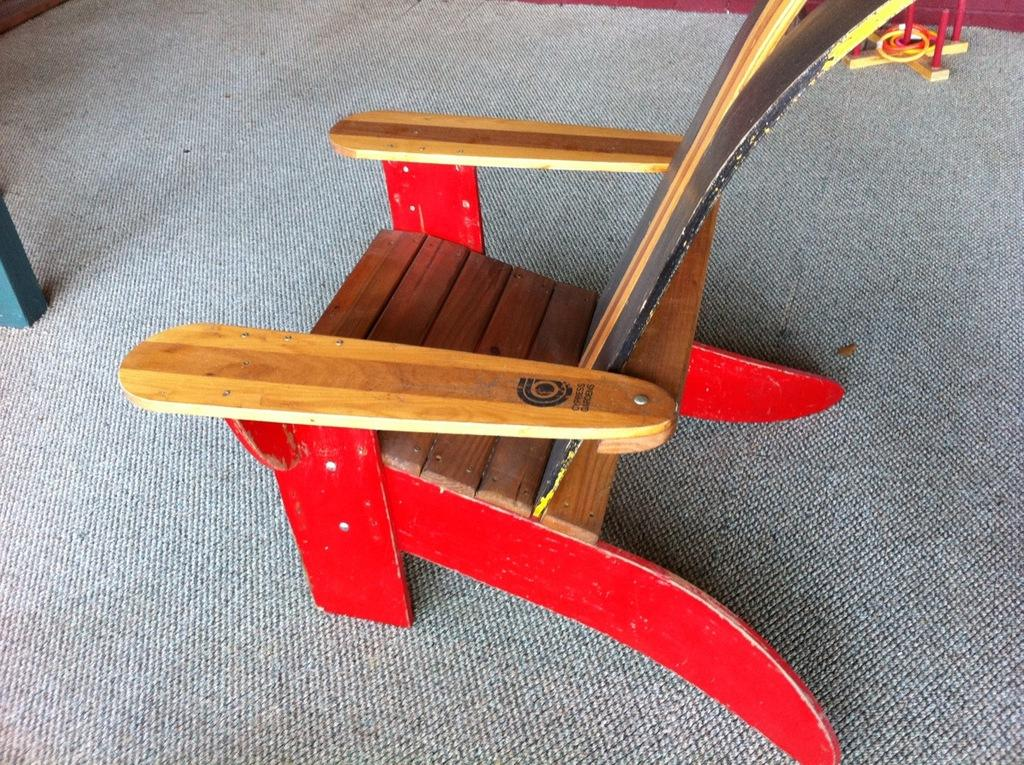What type of chair is in the image? There is a wooden chair in the image. What is on the floor in the image? There is a carpet on the floor in the image. How many books are stacked on the wooden chair in the image? There are no books visible in the image; only a wooden chair and a carpet on the floor are present. What type of pancake is being served on the carpet in the image? There is no pancake present in the image; only a wooden chair and a carpet on the floor are visible. 